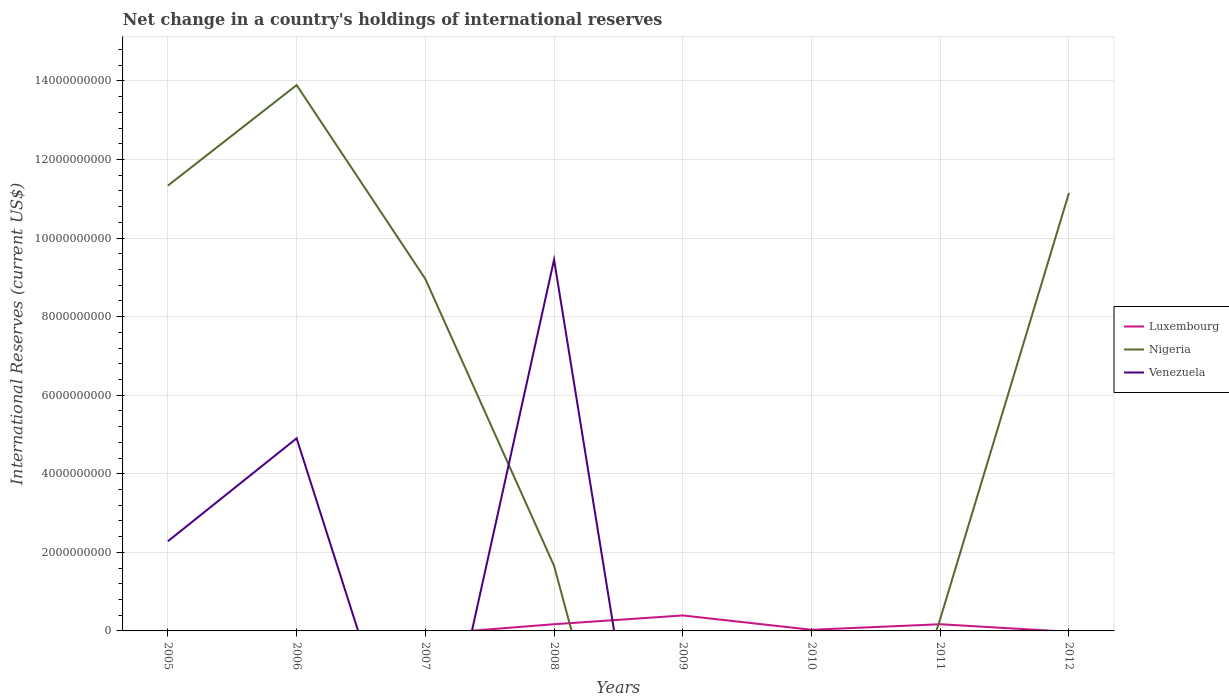How many different coloured lines are there?
Offer a terse response. 3. Does the line corresponding to Luxembourg intersect with the line corresponding to Nigeria?
Ensure brevity in your answer.  Yes. What is the total international reserves in Nigeria in the graph?
Offer a very short reply. 1.89e+08. What is the difference between the highest and the second highest international reserves in Luxembourg?
Ensure brevity in your answer.  3.94e+08. What is the difference between the highest and the lowest international reserves in Venezuela?
Give a very brief answer. 3. Is the international reserves in Nigeria strictly greater than the international reserves in Luxembourg over the years?
Provide a succinct answer. No. What is the difference between two consecutive major ticks on the Y-axis?
Ensure brevity in your answer.  2.00e+09. How many legend labels are there?
Your response must be concise. 3. What is the title of the graph?
Ensure brevity in your answer.  Net change in a country's holdings of international reserves. Does "Kuwait" appear as one of the legend labels in the graph?
Keep it short and to the point. No. What is the label or title of the X-axis?
Provide a succinct answer. Years. What is the label or title of the Y-axis?
Make the answer very short. International Reserves (current US$). What is the International Reserves (current US$) of Luxembourg in 2005?
Your answer should be very brief. 0. What is the International Reserves (current US$) in Nigeria in 2005?
Offer a very short reply. 1.13e+1. What is the International Reserves (current US$) of Venezuela in 2005?
Offer a terse response. 2.28e+09. What is the International Reserves (current US$) of Nigeria in 2006?
Give a very brief answer. 1.39e+1. What is the International Reserves (current US$) of Venezuela in 2006?
Give a very brief answer. 4.90e+09. What is the International Reserves (current US$) of Luxembourg in 2007?
Provide a succinct answer. 0. What is the International Reserves (current US$) of Nigeria in 2007?
Ensure brevity in your answer.  8.96e+09. What is the International Reserves (current US$) in Venezuela in 2007?
Make the answer very short. 0. What is the International Reserves (current US$) in Luxembourg in 2008?
Offer a very short reply. 1.71e+08. What is the International Reserves (current US$) in Nigeria in 2008?
Ensure brevity in your answer.  1.66e+09. What is the International Reserves (current US$) of Venezuela in 2008?
Your answer should be compact. 9.45e+09. What is the International Reserves (current US$) of Luxembourg in 2009?
Give a very brief answer. 3.94e+08. What is the International Reserves (current US$) of Nigeria in 2009?
Make the answer very short. 0. What is the International Reserves (current US$) of Luxembourg in 2010?
Offer a very short reply. 2.90e+07. What is the International Reserves (current US$) of Nigeria in 2010?
Make the answer very short. 0. What is the International Reserves (current US$) in Luxembourg in 2011?
Offer a very short reply. 1.70e+08. What is the International Reserves (current US$) of Nigeria in 2011?
Your answer should be compact. 3.06e+08. What is the International Reserves (current US$) in Venezuela in 2011?
Your answer should be compact. 0. What is the International Reserves (current US$) in Nigeria in 2012?
Make the answer very short. 1.11e+1. Across all years, what is the maximum International Reserves (current US$) in Luxembourg?
Your answer should be compact. 3.94e+08. Across all years, what is the maximum International Reserves (current US$) of Nigeria?
Your answer should be very brief. 1.39e+1. Across all years, what is the maximum International Reserves (current US$) of Venezuela?
Offer a terse response. 9.45e+09. What is the total International Reserves (current US$) in Luxembourg in the graph?
Provide a short and direct response. 7.64e+08. What is the total International Reserves (current US$) in Nigeria in the graph?
Provide a short and direct response. 4.73e+1. What is the total International Reserves (current US$) of Venezuela in the graph?
Your response must be concise. 1.66e+1. What is the difference between the International Reserves (current US$) in Nigeria in 2005 and that in 2006?
Provide a short and direct response. -2.56e+09. What is the difference between the International Reserves (current US$) of Venezuela in 2005 and that in 2006?
Provide a short and direct response. -2.62e+09. What is the difference between the International Reserves (current US$) in Nigeria in 2005 and that in 2007?
Give a very brief answer. 2.38e+09. What is the difference between the International Reserves (current US$) of Nigeria in 2005 and that in 2008?
Make the answer very short. 9.68e+09. What is the difference between the International Reserves (current US$) of Venezuela in 2005 and that in 2008?
Give a very brief answer. -7.17e+09. What is the difference between the International Reserves (current US$) in Nigeria in 2005 and that in 2011?
Your answer should be very brief. 1.10e+1. What is the difference between the International Reserves (current US$) in Nigeria in 2005 and that in 2012?
Keep it short and to the point. 1.89e+08. What is the difference between the International Reserves (current US$) of Nigeria in 2006 and that in 2007?
Offer a very short reply. 4.94e+09. What is the difference between the International Reserves (current US$) in Nigeria in 2006 and that in 2008?
Your answer should be very brief. 1.22e+1. What is the difference between the International Reserves (current US$) of Venezuela in 2006 and that in 2008?
Your answer should be very brief. -4.55e+09. What is the difference between the International Reserves (current US$) in Nigeria in 2006 and that in 2011?
Keep it short and to the point. 1.36e+1. What is the difference between the International Reserves (current US$) in Nigeria in 2006 and that in 2012?
Your answer should be compact. 2.75e+09. What is the difference between the International Reserves (current US$) in Nigeria in 2007 and that in 2008?
Ensure brevity in your answer.  7.30e+09. What is the difference between the International Reserves (current US$) of Nigeria in 2007 and that in 2011?
Give a very brief answer. 8.65e+09. What is the difference between the International Reserves (current US$) of Nigeria in 2007 and that in 2012?
Your response must be concise. -2.19e+09. What is the difference between the International Reserves (current US$) in Luxembourg in 2008 and that in 2009?
Offer a terse response. -2.23e+08. What is the difference between the International Reserves (current US$) of Luxembourg in 2008 and that in 2010?
Provide a succinct answer. 1.42e+08. What is the difference between the International Reserves (current US$) in Luxembourg in 2008 and that in 2011?
Keep it short and to the point. 3.41e+05. What is the difference between the International Reserves (current US$) in Nigeria in 2008 and that in 2011?
Make the answer very short. 1.35e+09. What is the difference between the International Reserves (current US$) of Nigeria in 2008 and that in 2012?
Offer a terse response. -9.49e+09. What is the difference between the International Reserves (current US$) in Luxembourg in 2009 and that in 2010?
Keep it short and to the point. 3.65e+08. What is the difference between the International Reserves (current US$) in Luxembourg in 2009 and that in 2011?
Offer a terse response. 2.24e+08. What is the difference between the International Reserves (current US$) of Luxembourg in 2010 and that in 2011?
Offer a terse response. -1.41e+08. What is the difference between the International Reserves (current US$) of Nigeria in 2011 and that in 2012?
Offer a terse response. -1.08e+1. What is the difference between the International Reserves (current US$) in Nigeria in 2005 and the International Reserves (current US$) in Venezuela in 2006?
Your answer should be compact. 6.43e+09. What is the difference between the International Reserves (current US$) of Nigeria in 2005 and the International Reserves (current US$) of Venezuela in 2008?
Give a very brief answer. 1.88e+09. What is the difference between the International Reserves (current US$) in Nigeria in 2006 and the International Reserves (current US$) in Venezuela in 2008?
Make the answer very short. 4.44e+09. What is the difference between the International Reserves (current US$) in Nigeria in 2007 and the International Reserves (current US$) in Venezuela in 2008?
Your answer should be very brief. -4.94e+08. What is the difference between the International Reserves (current US$) of Luxembourg in 2008 and the International Reserves (current US$) of Nigeria in 2011?
Offer a terse response. -1.35e+08. What is the difference between the International Reserves (current US$) of Luxembourg in 2008 and the International Reserves (current US$) of Nigeria in 2012?
Your answer should be very brief. -1.10e+1. What is the difference between the International Reserves (current US$) of Luxembourg in 2009 and the International Reserves (current US$) of Nigeria in 2011?
Offer a terse response. 8.81e+07. What is the difference between the International Reserves (current US$) of Luxembourg in 2009 and the International Reserves (current US$) of Nigeria in 2012?
Your answer should be compact. -1.08e+1. What is the difference between the International Reserves (current US$) in Luxembourg in 2010 and the International Reserves (current US$) in Nigeria in 2011?
Keep it short and to the point. -2.77e+08. What is the difference between the International Reserves (current US$) in Luxembourg in 2010 and the International Reserves (current US$) in Nigeria in 2012?
Your answer should be compact. -1.11e+1. What is the difference between the International Reserves (current US$) of Luxembourg in 2011 and the International Reserves (current US$) of Nigeria in 2012?
Ensure brevity in your answer.  -1.10e+1. What is the average International Reserves (current US$) of Luxembourg per year?
Make the answer very short. 9.55e+07. What is the average International Reserves (current US$) in Nigeria per year?
Make the answer very short. 5.91e+09. What is the average International Reserves (current US$) in Venezuela per year?
Your answer should be compact. 2.08e+09. In the year 2005, what is the difference between the International Reserves (current US$) of Nigeria and International Reserves (current US$) of Venezuela?
Your answer should be compact. 9.05e+09. In the year 2006, what is the difference between the International Reserves (current US$) of Nigeria and International Reserves (current US$) of Venezuela?
Keep it short and to the point. 8.99e+09. In the year 2008, what is the difference between the International Reserves (current US$) of Luxembourg and International Reserves (current US$) of Nigeria?
Provide a short and direct response. -1.49e+09. In the year 2008, what is the difference between the International Reserves (current US$) of Luxembourg and International Reserves (current US$) of Venezuela?
Provide a short and direct response. -9.28e+09. In the year 2008, what is the difference between the International Reserves (current US$) in Nigeria and International Reserves (current US$) in Venezuela?
Provide a succinct answer. -7.80e+09. In the year 2011, what is the difference between the International Reserves (current US$) in Luxembourg and International Reserves (current US$) in Nigeria?
Keep it short and to the point. -1.36e+08. What is the ratio of the International Reserves (current US$) of Nigeria in 2005 to that in 2006?
Make the answer very short. 0.82. What is the ratio of the International Reserves (current US$) in Venezuela in 2005 to that in 2006?
Offer a terse response. 0.47. What is the ratio of the International Reserves (current US$) in Nigeria in 2005 to that in 2007?
Ensure brevity in your answer.  1.27. What is the ratio of the International Reserves (current US$) of Nigeria in 2005 to that in 2008?
Give a very brief answer. 6.84. What is the ratio of the International Reserves (current US$) in Venezuela in 2005 to that in 2008?
Ensure brevity in your answer.  0.24. What is the ratio of the International Reserves (current US$) of Nigeria in 2005 to that in 2011?
Give a very brief answer. 37.06. What is the ratio of the International Reserves (current US$) of Nigeria in 2006 to that in 2007?
Your answer should be compact. 1.55. What is the ratio of the International Reserves (current US$) in Nigeria in 2006 to that in 2008?
Your answer should be compact. 8.38. What is the ratio of the International Reserves (current US$) of Venezuela in 2006 to that in 2008?
Your response must be concise. 0.52. What is the ratio of the International Reserves (current US$) in Nigeria in 2006 to that in 2011?
Your response must be concise. 45.43. What is the ratio of the International Reserves (current US$) in Nigeria in 2006 to that in 2012?
Offer a very short reply. 1.25. What is the ratio of the International Reserves (current US$) in Nigeria in 2007 to that in 2008?
Ensure brevity in your answer.  5.41. What is the ratio of the International Reserves (current US$) of Nigeria in 2007 to that in 2011?
Ensure brevity in your answer.  29.29. What is the ratio of the International Reserves (current US$) of Nigeria in 2007 to that in 2012?
Your answer should be very brief. 0.8. What is the ratio of the International Reserves (current US$) of Luxembourg in 2008 to that in 2009?
Your response must be concise. 0.43. What is the ratio of the International Reserves (current US$) of Luxembourg in 2008 to that in 2010?
Offer a terse response. 5.88. What is the ratio of the International Reserves (current US$) in Nigeria in 2008 to that in 2011?
Offer a terse response. 5.42. What is the ratio of the International Reserves (current US$) in Nigeria in 2008 to that in 2012?
Make the answer very short. 0.15. What is the ratio of the International Reserves (current US$) in Luxembourg in 2009 to that in 2010?
Offer a very short reply. 13.58. What is the ratio of the International Reserves (current US$) in Luxembourg in 2009 to that in 2011?
Offer a terse response. 2.31. What is the ratio of the International Reserves (current US$) of Luxembourg in 2010 to that in 2011?
Give a very brief answer. 0.17. What is the ratio of the International Reserves (current US$) of Nigeria in 2011 to that in 2012?
Your response must be concise. 0.03. What is the difference between the highest and the second highest International Reserves (current US$) in Luxembourg?
Keep it short and to the point. 2.23e+08. What is the difference between the highest and the second highest International Reserves (current US$) of Nigeria?
Make the answer very short. 2.56e+09. What is the difference between the highest and the second highest International Reserves (current US$) in Venezuela?
Provide a succinct answer. 4.55e+09. What is the difference between the highest and the lowest International Reserves (current US$) in Luxembourg?
Make the answer very short. 3.94e+08. What is the difference between the highest and the lowest International Reserves (current US$) in Nigeria?
Keep it short and to the point. 1.39e+1. What is the difference between the highest and the lowest International Reserves (current US$) of Venezuela?
Provide a short and direct response. 9.45e+09. 